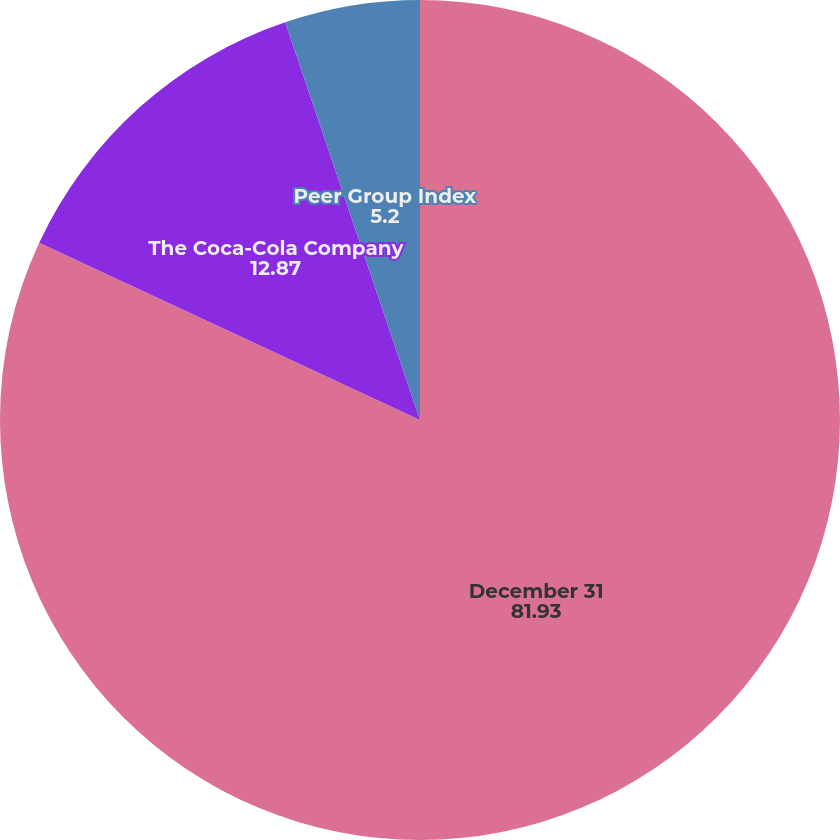<chart> <loc_0><loc_0><loc_500><loc_500><pie_chart><fcel>December 31<fcel>The Coca-Cola Company<fcel>Peer Group Index<nl><fcel>81.93%<fcel>12.87%<fcel>5.2%<nl></chart> 